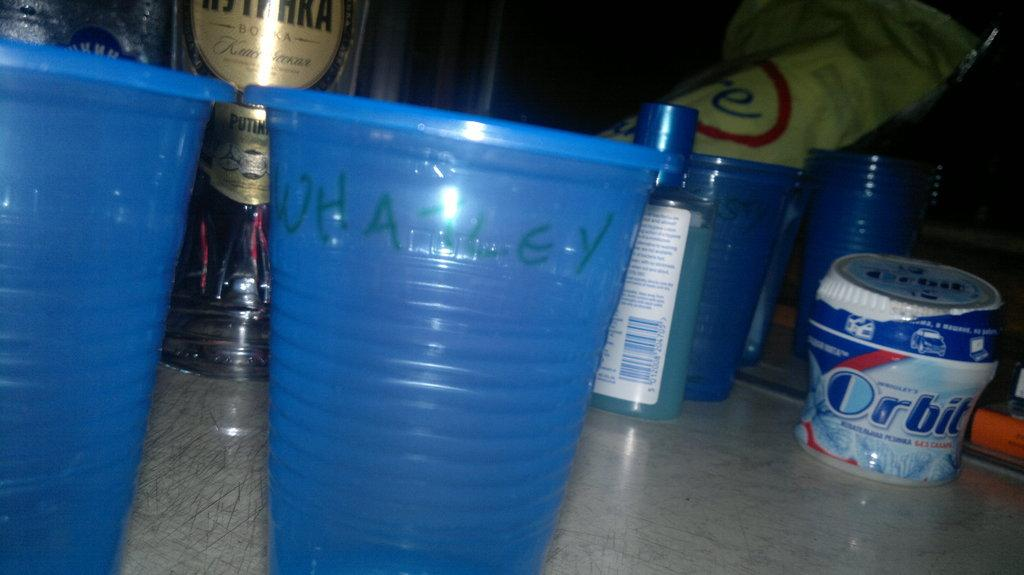<image>
Summarize the visual content of the image. A canister next to cups has the Orbit label on it. 